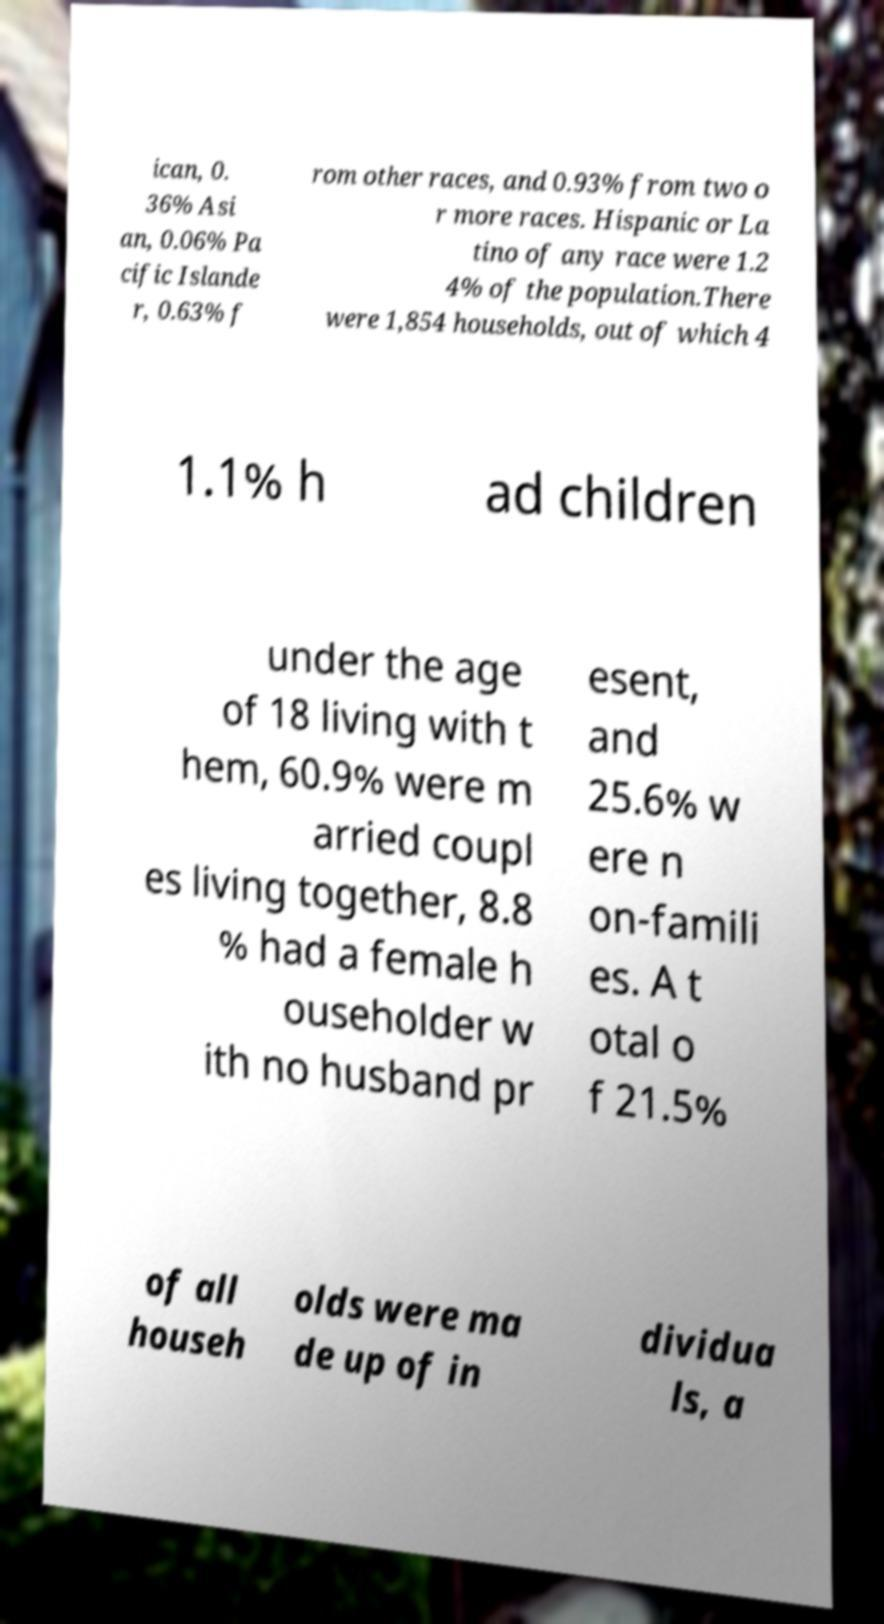Could you extract and type out the text from this image? ican, 0. 36% Asi an, 0.06% Pa cific Islande r, 0.63% f rom other races, and 0.93% from two o r more races. Hispanic or La tino of any race were 1.2 4% of the population.There were 1,854 households, out of which 4 1.1% h ad children under the age of 18 living with t hem, 60.9% were m arried coupl es living together, 8.8 % had a female h ouseholder w ith no husband pr esent, and 25.6% w ere n on-famili es. A t otal o f 21.5% of all househ olds were ma de up of in dividua ls, a 